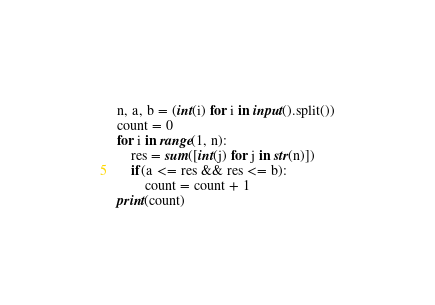<code> <loc_0><loc_0><loc_500><loc_500><_Python_>n, a, b = (int(i) for i in input().split())
count = 0
for i in range(1, n):
    res = sum([int(j) for j in str(n)])
    if(a <= res && res <= b):
        count = count + 1
print(count)</code> 